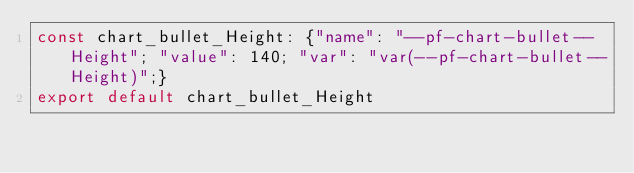Convert code to text. <code><loc_0><loc_0><loc_500><loc_500><_TypeScript_>const chart_bullet_Height: {"name": "--pf-chart-bullet--Height"; "value": 140; "var": "var(--pf-chart-bullet--Height)";}
export default chart_bullet_Height
</code> 